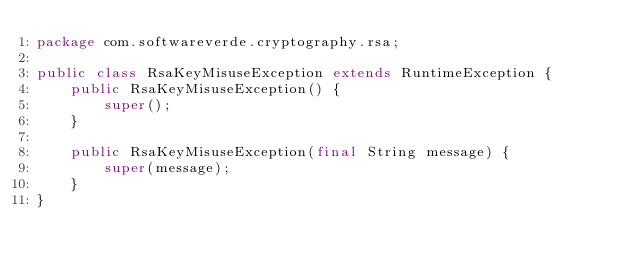<code> <loc_0><loc_0><loc_500><loc_500><_Java_>package com.softwareverde.cryptography.rsa;

public class RsaKeyMisuseException extends RuntimeException {
    public RsaKeyMisuseException() {
        super();
    }

    public RsaKeyMisuseException(final String message) {
        super(message);
    }
}
</code> 